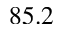Convert formula to latex. <formula><loc_0><loc_0><loc_500><loc_500>8 5 . 2</formula> 